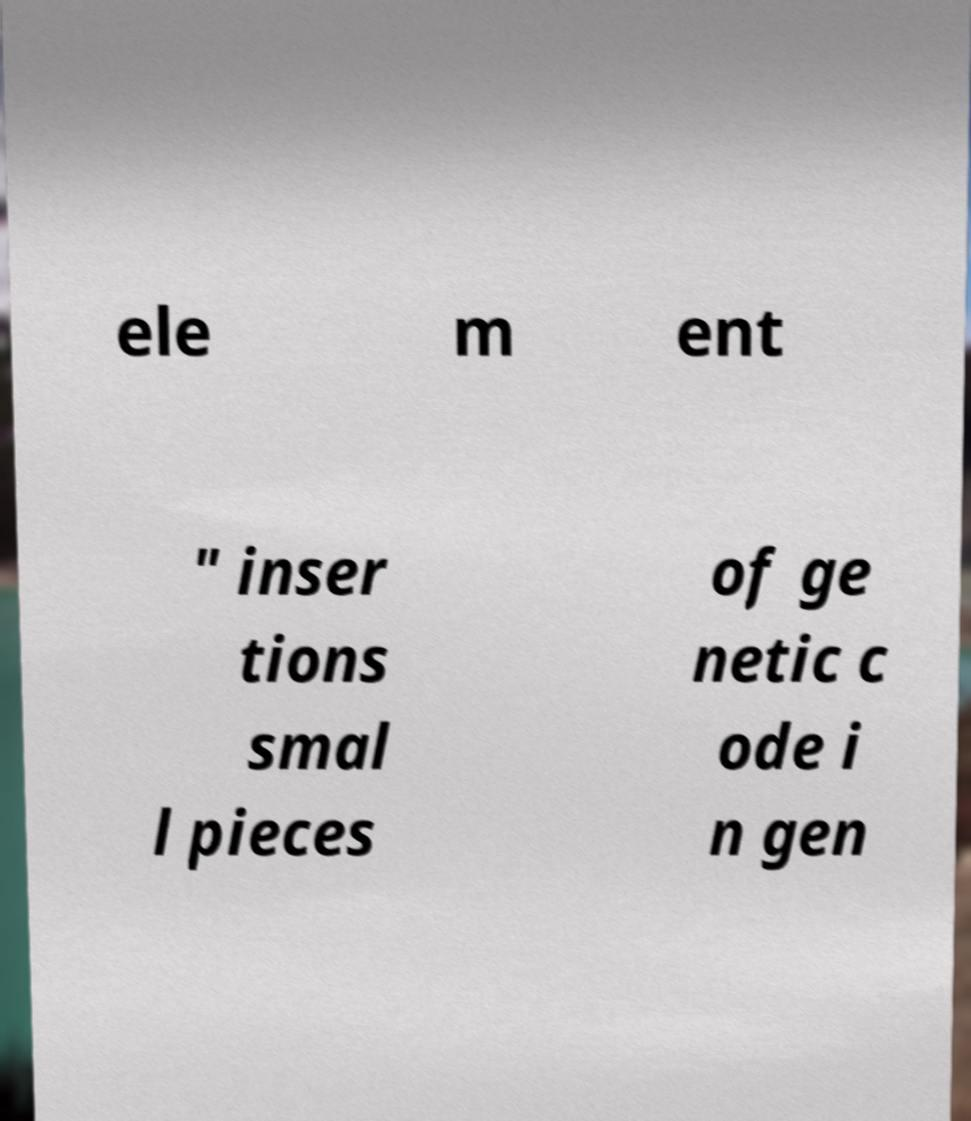I need the written content from this picture converted into text. Can you do that? ele m ent " inser tions smal l pieces of ge netic c ode i n gen 